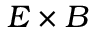Convert formula to latex. <formula><loc_0><loc_0><loc_500><loc_500>{ E } \times { B }</formula> 